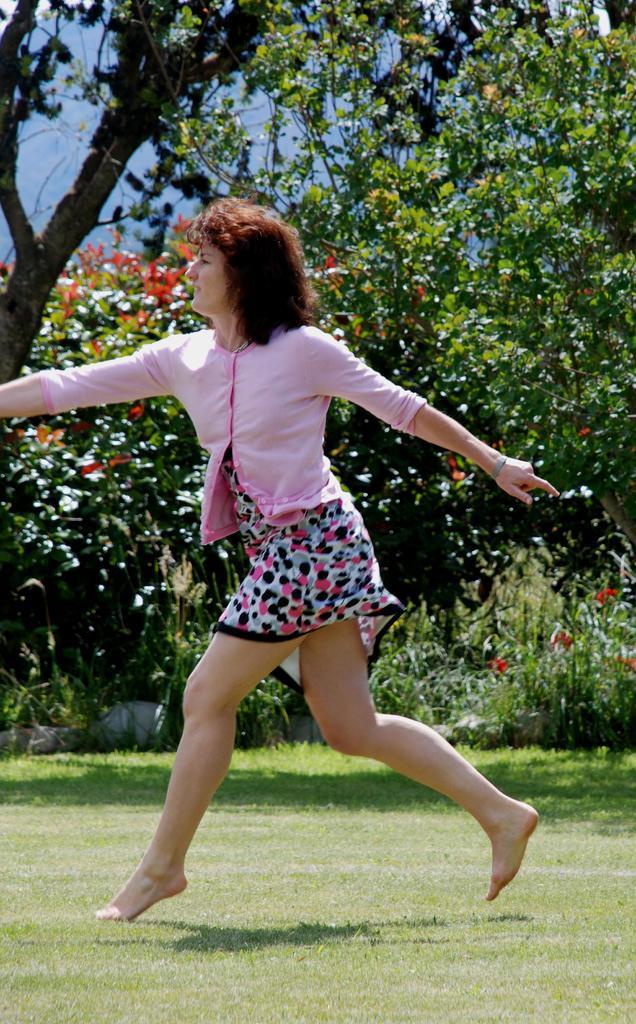In one or two sentences, can you explain what this image depicts? In the center of the image we can see a woman. Image also consists of trees, plants and also the grass. Some part of the sky is also visible. 